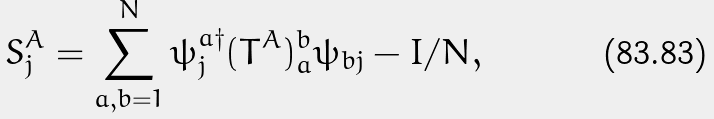Convert formula to latex. <formula><loc_0><loc_0><loc_500><loc_500>S ^ { A } _ { j } = \sum _ { a , b = 1 } ^ { N } \psi ^ { a \dagger } _ { j } ( T ^ { A } ) ^ { b } _ { a } \psi _ { b j } - { I / N } ,</formula> 